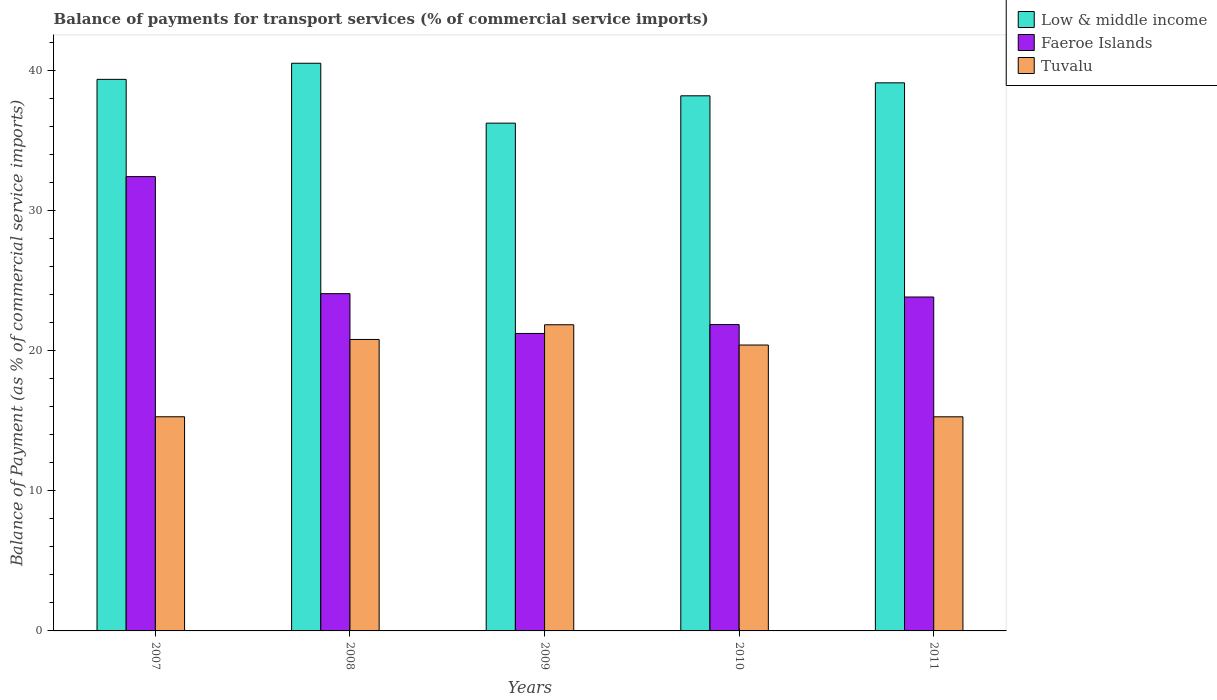Are the number of bars on each tick of the X-axis equal?
Provide a succinct answer. Yes. How many bars are there on the 5th tick from the left?
Your answer should be compact. 3. How many bars are there on the 5th tick from the right?
Make the answer very short. 3. What is the label of the 4th group of bars from the left?
Your response must be concise. 2010. What is the balance of payments for transport services in Faeroe Islands in 2010?
Your answer should be compact. 21.87. Across all years, what is the maximum balance of payments for transport services in Low & middle income?
Offer a terse response. 40.52. Across all years, what is the minimum balance of payments for transport services in Tuvalu?
Your answer should be compact. 15.28. In which year was the balance of payments for transport services in Low & middle income minimum?
Make the answer very short. 2009. What is the total balance of payments for transport services in Low & middle income in the graph?
Your response must be concise. 193.44. What is the difference between the balance of payments for transport services in Faeroe Islands in 2007 and that in 2011?
Give a very brief answer. 8.59. What is the difference between the balance of payments for transport services in Faeroe Islands in 2011 and the balance of payments for transport services in Tuvalu in 2008?
Offer a very short reply. 3.03. What is the average balance of payments for transport services in Low & middle income per year?
Your answer should be compact. 38.69. In the year 2008, what is the difference between the balance of payments for transport services in Tuvalu and balance of payments for transport services in Faeroe Islands?
Give a very brief answer. -3.27. In how many years, is the balance of payments for transport services in Low & middle income greater than 16 %?
Your response must be concise. 5. What is the ratio of the balance of payments for transport services in Low & middle income in 2008 to that in 2009?
Provide a succinct answer. 1.12. What is the difference between the highest and the second highest balance of payments for transport services in Low & middle income?
Offer a very short reply. 1.15. What is the difference between the highest and the lowest balance of payments for transport services in Faeroe Islands?
Offer a terse response. 11.19. In how many years, is the balance of payments for transport services in Low & middle income greater than the average balance of payments for transport services in Low & middle income taken over all years?
Provide a succinct answer. 3. Is the sum of the balance of payments for transport services in Faeroe Islands in 2007 and 2009 greater than the maximum balance of payments for transport services in Low & middle income across all years?
Keep it short and to the point. Yes. What does the 2nd bar from the left in 2008 represents?
Ensure brevity in your answer.  Faeroe Islands. What does the 3rd bar from the right in 2011 represents?
Give a very brief answer. Low & middle income. Is it the case that in every year, the sum of the balance of payments for transport services in Tuvalu and balance of payments for transport services in Low & middle income is greater than the balance of payments for transport services in Faeroe Islands?
Your answer should be very brief. Yes. How many years are there in the graph?
Provide a succinct answer. 5. What is the difference between two consecutive major ticks on the Y-axis?
Your answer should be compact. 10. Are the values on the major ticks of Y-axis written in scientific E-notation?
Offer a terse response. No. Does the graph contain grids?
Provide a short and direct response. No. Where does the legend appear in the graph?
Keep it short and to the point. Top right. How many legend labels are there?
Provide a short and direct response. 3. What is the title of the graph?
Offer a very short reply. Balance of payments for transport services (% of commercial service imports). Does "South Africa" appear as one of the legend labels in the graph?
Offer a very short reply. No. What is the label or title of the X-axis?
Offer a terse response. Years. What is the label or title of the Y-axis?
Provide a short and direct response. Balance of Payment (as % of commercial service imports). What is the Balance of Payment (as % of commercial service imports) in Low & middle income in 2007?
Your answer should be very brief. 39.37. What is the Balance of Payment (as % of commercial service imports) in Faeroe Islands in 2007?
Your answer should be compact. 32.43. What is the Balance of Payment (as % of commercial service imports) of Tuvalu in 2007?
Ensure brevity in your answer.  15.28. What is the Balance of Payment (as % of commercial service imports) of Low & middle income in 2008?
Provide a succinct answer. 40.52. What is the Balance of Payment (as % of commercial service imports) of Faeroe Islands in 2008?
Your response must be concise. 24.07. What is the Balance of Payment (as % of commercial service imports) in Tuvalu in 2008?
Provide a succinct answer. 20.8. What is the Balance of Payment (as % of commercial service imports) in Low & middle income in 2009?
Your answer should be compact. 36.24. What is the Balance of Payment (as % of commercial service imports) of Faeroe Islands in 2009?
Offer a very short reply. 21.23. What is the Balance of Payment (as % of commercial service imports) in Tuvalu in 2009?
Make the answer very short. 21.85. What is the Balance of Payment (as % of commercial service imports) of Low & middle income in 2010?
Offer a terse response. 38.19. What is the Balance of Payment (as % of commercial service imports) in Faeroe Islands in 2010?
Provide a short and direct response. 21.87. What is the Balance of Payment (as % of commercial service imports) in Tuvalu in 2010?
Offer a terse response. 20.41. What is the Balance of Payment (as % of commercial service imports) in Low & middle income in 2011?
Your response must be concise. 39.12. What is the Balance of Payment (as % of commercial service imports) of Faeroe Islands in 2011?
Ensure brevity in your answer.  23.83. What is the Balance of Payment (as % of commercial service imports) in Tuvalu in 2011?
Ensure brevity in your answer.  15.28. Across all years, what is the maximum Balance of Payment (as % of commercial service imports) in Low & middle income?
Keep it short and to the point. 40.52. Across all years, what is the maximum Balance of Payment (as % of commercial service imports) of Faeroe Islands?
Keep it short and to the point. 32.43. Across all years, what is the maximum Balance of Payment (as % of commercial service imports) of Tuvalu?
Offer a terse response. 21.85. Across all years, what is the minimum Balance of Payment (as % of commercial service imports) in Low & middle income?
Give a very brief answer. 36.24. Across all years, what is the minimum Balance of Payment (as % of commercial service imports) in Faeroe Islands?
Make the answer very short. 21.23. Across all years, what is the minimum Balance of Payment (as % of commercial service imports) of Tuvalu?
Offer a very short reply. 15.28. What is the total Balance of Payment (as % of commercial service imports) of Low & middle income in the graph?
Offer a terse response. 193.44. What is the total Balance of Payment (as % of commercial service imports) in Faeroe Islands in the graph?
Your answer should be compact. 123.43. What is the total Balance of Payment (as % of commercial service imports) of Tuvalu in the graph?
Keep it short and to the point. 93.63. What is the difference between the Balance of Payment (as % of commercial service imports) of Low & middle income in 2007 and that in 2008?
Offer a terse response. -1.15. What is the difference between the Balance of Payment (as % of commercial service imports) of Faeroe Islands in 2007 and that in 2008?
Provide a succinct answer. 8.35. What is the difference between the Balance of Payment (as % of commercial service imports) in Tuvalu in 2007 and that in 2008?
Provide a succinct answer. -5.52. What is the difference between the Balance of Payment (as % of commercial service imports) in Low & middle income in 2007 and that in 2009?
Your answer should be very brief. 3.13. What is the difference between the Balance of Payment (as % of commercial service imports) in Faeroe Islands in 2007 and that in 2009?
Your answer should be very brief. 11.19. What is the difference between the Balance of Payment (as % of commercial service imports) of Tuvalu in 2007 and that in 2009?
Offer a very short reply. -6.57. What is the difference between the Balance of Payment (as % of commercial service imports) of Low & middle income in 2007 and that in 2010?
Offer a very short reply. 1.17. What is the difference between the Balance of Payment (as % of commercial service imports) in Faeroe Islands in 2007 and that in 2010?
Make the answer very short. 10.56. What is the difference between the Balance of Payment (as % of commercial service imports) of Tuvalu in 2007 and that in 2010?
Provide a short and direct response. -5.12. What is the difference between the Balance of Payment (as % of commercial service imports) in Low & middle income in 2007 and that in 2011?
Keep it short and to the point. 0.25. What is the difference between the Balance of Payment (as % of commercial service imports) of Faeroe Islands in 2007 and that in 2011?
Keep it short and to the point. 8.59. What is the difference between the Balance of Payment (as % of commercial service imports) in Tuvalu in 2007 and that in 2011?
Offer a very short reply. 0. What is the difference between the Balance of Payment (as % of commercial service imports) in Low & middle income in 2008 and that in 2009?
Offer a very short reply. 4.27. What is the difference between the Balance of Payment (as % of commercial service imports) in Faeroe Islands in 2008 and that in 2009?
Offer a terse response. 2.84. What is the difference between the Balance of Payment (as % of commercial service imports) of Tuvalu in 2008 and that in 2009?
Your response must be concise. -1.05. What is the difference between the Balance of Payment (as % of commercial service imports) of Low & middle income in 2008 and that in 2010?
Your answer should be very brief. 2.32. What is the difference between the Balance of Payment (as % of commercial service imports) in Faeroe Islands in 2008 and that in 2010?
Ensure brevity in your answer.  2.21. What is the difference between the Balance of Payment (as % of commercial service imports) of Tuvalu in 2008 and that in 2010?
Ensure brevity in your answer.  0.4. What is the difference between the Balance of Payment (as % of commercial service imports) of Low & middle income in 2008 and that in 2011?
Your answer should be very brief. 1.4. What is the difference between the Balance of Payment (as % of commercial service imports) in Faeroe Islands in 2008 and that in 2011?
Your response must be concise. 0.24. What is the difference between the Balance of Payment (as % of commercial service imports) in Tuvalu in 2008 and that in 2011?
Your answer should be compact. 5.52. What is the difference between the Balance of Payment (as % of commercial service imports) of Low & middle income in 2009 and that in 2010?
Your answer should be very brief. -1.95. What is the difference between the Balance of Payment (as % of commercial service imports) in Faeroe Islands in 2009 and that in 2010?
Keep it short and to the point. -0.63. What is the difference between the Balance of Payment (as % of commercial service imports) in Tuvalu in 2009 and that in 2010?
Your answer should be very brief. 1.45. What is the difference between the Balance of Payment (as % of commercial service imports) of Low & middle income in 2009 and that in 2011?
Your answer should be very brief. -2.88. What is the difference between the Balance of Payment (as % of commercial service imports) of Faeroe Islands in 2009 and that in 2011?
Give a very brief answer. -2.6. What is the difference between the Balance of Payment (as % of commercial service imports) of Tuvalu in 2009 and that in 2011?
Provide a succinct answer. 6.57. What is the difference between the Balance of Payment (as % of commercial service imports) of Low & middle income in 2010 and that in 2011?
Give a very brief answer. -0.93. What is the difference between the Balance of Payment (as % of commercial service imports) of Faeroe Islands in 2010 and that in 2011?
Provide a succinct answer. -1.97. What is the difference between the Balance of Payment (as % of commercial service imports) in Tuvalu in 2010 and that in 2011?
Offer a very short reply. 5.12. What is the difference between the Balance of Payment (as % of commercial service imports) in Low & middle income in 2007 and the Balance of Payment (as % of commercial service imports) in Faeroe Islands in 2008?
Offer a very short reply. 15.3. What is the difference between the Balance of Payment (as % of commercial service imports) in Low & middle income in 2007 and the Balance of Payment (as % of commercial service imports) in Tuvalu in 2008?
Provide a short and direct response. 18.56. What is the difference between the Balance of Payment (as % of commercial service imports) in Faeroe Islands in 2007 and the Balance of Payment (as % of commercial service imports) in Tuvalu in 2008?
Your response must be concise. 11.62. What is the difference between the Balance of Payment (as % of commercial service imports) in Low & middle income in 2007 and the Balance of Payment (as % of commercial service imports) in Faeroe Islands in 2009?
Ensure brevity in your answer.  18.14. What is the difference between the Balance of Payment (as % of commercial service imports) in Low & middle income in 2007 and the Balance of Payment (as % of commercial service imports) in Tuvalu in 2009?
Make the answer very short. 17.52. What is the difference between the Balance of Payment (as % of commercial service imports) of Faeroe Islands in 2007 and the Balance of Payment (as % of commercial service imports) of Tuvalu in 2009?
Make the answer very short. 10.57. What is the difference between the Balance of Payment (as % of commercial service imports) of Low & middle income in 2007 and the Balance of Payment (as % of commercial service imports) of Faeroe Islands in 2010?
Offer a very short reply. 17.5. What is the difference between the Balance of Payment (as % of commercial service imports) of Low & middle income in 2007 and the Balance of Payment (as % of commercial service imports) of Tuvalu in 2010?
Offer a very short reply. 18.96. What is the difference between the Balance of Payment (as % of commercial service imports) in Faeroe Islands in 2007 and the Balance of Payment (as % of commercial service imports) in Tuvalu in 2010?
Your answer should be very brief. 12.02. What is the difference between the Balance of Payment (as % of commercial service imports) of Low & middle income in 2007 and the Balance of Payment (as % of commercial service imports) of Faeroe Islands in 2011?
Ensure brevity in your answer.  15.53. What is the difference between the Balance of Payment (as % of commercial service imports) of Low & middle income in 2007 and the Balance of Payment (as % of commercial service imports) of Tuvalu in 2011?
Provide a succinct answer. 24.09. What is the difference between the Balance of Payment (as % of commercial service imports) of Faeroe Islands in 2007 and the Balance of Payment (as % of commercial service imports) of Tuvalu in 2011?
Provide a succinct answer. 17.14. What is the difference between the Balance of Payment (as % of commercial service imports) in Low & middle income in 2008 and the Balance of Payment (as % of commercial service imports) in Faeroe Islands in 2009?
Your response must be concise. 19.29. What is the difference between the Balance of Payment (as % of commercial service imports) of Low & middle income in 2008 and the Balance of Payment (as % of commercial service imports) of Tuvalu in 2009?
Provide a short and direct response. 18.66. What is the difference between the Balance of Payment (as % of commercial service imports) in Faeroe Islands in 2008 and the Balance of Payment (as % of commercial service imports) in Tuvalu in 2009?
Provide a short and direct response. 2.22. What is the difference between the Balance of Payment (as % of commercial service imports) of Low & middle income in 2008 and the Balance of Payment (as % of commercial service imports) of Faeroe Islands in 2010?
Your response must be concise. 18.65. What is the difference between the Balance of Payment (as % of commercial service imports) in Low & middle income in 2008 and the Balance of Payment (as % of commercial service imports) in Tuvalu in 2010?
Your response must be concise. 20.11. What is the difference between the Balance of Payment (as % of commercial service imports) of Faeroe Islands in 2008 and the Balance of Payment (as % of commercial service imports) of Tuvalu in 2010?
Offer a terse response. 3.67. What is the difference between the Balance of Payment (as % of commercial service imports) of Low & middle income in 2008 and the Balance of Payment (as % of commercial service imports) of Faeroe Islands in 2011?
Your response must be concise. 16.68. What is the difference between the Balance of Payment (as % of commercial service imports) of Low & middle income in 2008 and the Balance of Payment (as % of commercial service imports) of Tuvalu in 2011?
Keep it short and to the point. 25.23. What is the difference between the Balance of Payment (as % of commercial service imports) of Faeroe Islands in 2008 and the Balance of Payment (as % of commercial service imports) of Tuvalu in 2011?
Offer a very short reply. 8.79. What is the difference between the Balance of Payment (as % of commercial service imports) in Low & middle income in 2009 and the Balance of Payment (as % of commercial service imports) in Faeroe Islands in 2010?
Your answer should be very brief. 14.38. What is the difference between the Balance of Payment (as % of commercial service imports) of Low & middle income in 2009 and the Balance of Payment (as % of commercial service imports) of Tuvalu in 2010?
Provide a succinct answer. 15.84. What is the difference between the Balance of Payment (as % of commercial service imports) of Faeroe Islands in 2009 and the Balance of Payment (as % of commercial service imports) of Tuvalu in 2010?
Your answer should be compact. 0.83. What is the difference between the Balance of Payment (as % of commercial service imports) in Low & middle income in 2009 and the Balance of Payment (as % of commercial service imports) in Faeroe Islands in 2011?
Make the answer very short. 12.41. What is the difference between the Balance of Payment (as % of commercial service imports) in Low & middle income in 2009 and the Balance of Payment (as % of commercial service imports) in Tuvalu in 2011?
Offer a very short reply. 20.96. What is the difference between the Balance of Payment (as % of commercial service imports) of Faeroe Islands in 2009 and the Balance of Payment (as % of commercial service imports) of Tuvalu in 2011?
Make the answer very short. 5.95. What is the difference between the Balance of Payment (as % of commercial service imports) in Low & middle income in 2010 and the Balance of Payment (as % of commercial service imports) in Faeroe Islands in 2011?
Your answer should be very brief. 14.36. What is the difference between the Balance of Payment (as % of commercial service imports) of Low & middle income in 2010 and the Balance of Payment (as % of commercial service imports) of Tuvalu in 2011?
Ensure brevity in your answer.  22.91. What is the difference between the Balance of Payment (as % of commercial service imports) of Faeroe Islands in 2010 and the Balance of Payment (as % of commercial service imports) of Tuvalu in 2011?
Offer a terse response. 6.58. What is the average Balance of Payment (as % of commercial service imports) in Low & middle income per year?
Offer a very short reply. 38.69. What is the average Balance of Payment (as % of commercial service imports) in Faeroe Islands per year?
Make the answer very short. 24.69. What is the average Balance of Payment (as % of commercial service imports) in Tuvalu per year?
Offer a terse response. 18.73. In the year 2007, what is the difference between the Balance of Payment (as % of commercial service imports) of Low & middle income and Balance of Payment (as % of commercial service imports) of Faeroe Islands?
Your answer should be compact. 6.94. In the year 2007, what is the difference between the Balance of Payment (as % of commercial service imports) of Low & middle income and Balance of Payment (as % of commercial service imports) of Tuvalu?
Your answer should be compact. 24.08. In the year 2007, what is the difference between the Balance of Payment (as % of commercial service imports) in Faeroe Islands and Balance of Payment (as % of commercial service imports) in Tuvalu?
Provide a succinct answer. 17.14. In the year 2008, what is the difference between the Balance of Payment (as % of commercial service imports) of Low & middle income and Balance of Payment (as % of commercial service imports) of Faeroe Islands?
Make the answer very short. 16.45. In the year 2008, what is the difference between the Balance of Payment (as % of commercial service imports) of Low & middle income and Balance of Payment (as % of commercial service imports) of Tuvalu?
Your response must be concise. 19.71. In the year 2008, what is the difference between the Balance of Payment (as % of commercial service imports) in Faeroe Islands and Balance of Payment (as % of commercial service imports) in Tuvalu?
Provide a short and direct response. 3.27. In the year 2009, what is the difference between the Balance of Payment (as % of commercial service imports) of Low & middle income and Balance of Payment (as % of commercial service imports) of Faeroe Islands?
Offer a terse response. 15.01. In the year 2009, what is the difference between the Balance of Payment (as % of commercial service imports) in Low & middle income and Balance of Payment (as % of commercial service imports) in Tuvalu?
Keep it short and to the point. 14.39. In the year 2009, what is the difference between the Balance of Payment (as % of commercial service imports) of Faeroe Islands and Balance of Payment (as % of commercial service imports) of Tuvalu?
Provide a short and direct response. -0.62. In the year 2010, what is the difference between the Balance of Payment (as % of commercial service imports) in Low & middle income and Balance of Payment (as % of commercial service imports) in Faeroe Islands?
Keep it short and to the point. 16.33. In the year 2010, what is the difference between the Balance of Payment (as % of commercial service imports) in Low & middle income and Balance of Payment (as % of commercial service imports) in Tuvalu?
Your answer should be very brief. 17.79. In the year 2010, what is the difference between the Balance of Payment (as % of commercial service imports) of Faeroe Islands and Balance of Payment (as % of commercial service imports) of Tuvalu?
Offer a terse response. 1.46. In the year 2011, what is the difference between the Balance of Payment (as % of commercial service imports) of Low & middle income and Balance of Payment (as % of commercial service imports) of Faeroe Islands?
Your response must be concise. 15.29. In the year 2011, what is the difference between the Balance of Payment (as % of commercial service imports) of Low & middle income and Balance of Payment (as % of commercial service imports) of Tuvalu?
Your answer should be very brief. 23.84. In the year 2011, what is the difference between the Balance of Payment (as % of commercial service imports) of Faeroe Islands and Balance of Payment (as % of commercial service imports) of Tuvalu?
Your answer should be very brief. 8.55. What is the ratio of the Balance of Payment (as % of commercial service imports) in Low & middle income in 2007 to that in 2008?
Make the answer very short. 0.97. What is the ratio of the Balance of Payment (as % of commercial service imports) in Faeroe Islands in 2007 to that in 2008?
Your answer should be very brief. 1.35. What is the ratio of the Balance of Payment (as % of commercial service imports) of Tuvalu in 2007 to that in 2008?
Ensure brevity in your answer.  0.73. What is the ratio of the Balance of Payment (as % of commercial service imports) in Low & middle income in 2007 to that in 2009?
Keep it short and to the point. 1.09. What is the ratio of the Balance of Payment (as % of commercial service imports) of Faeroe Islands in 2007 to that in 2009?
Make the answer very short. 1.53. What is the ratio of the Balance of Payment (as % of commercial service imports) of Tuvalu in 2007 to that in 2009?
Make the answer very short. 0.7. What is the ratio of the Balance of Payment (as % of commercial service imports) of Low & middle income in 2007 to that in 2010?
Offer a terse response. 1.03. What is the ratio of the Balance of Payment (as % of commercial service imports) in Faeroe Islands in 2007 to that in 2010?
Your response must be concise. 1.48. What is the ratio of the Balance of Payment (as % of commercial service imports) of Tuvalu in 2007 to that in 2010?
Give a very brief answer. 0.75. What is the ratio of the Balance of Payment (as % of commercial service imports) in Faeroe Islands in 2007 to that in 2011?
Your response must be concise. 1.36. What is the ratio of the Balance of Payment (as % of commercial service imports) of Low & middle income in 2008 to that in 2009?
Provide a succinct answer. 1.12. What is the ratio of the Balance of Payment (as % of commercial service imports) in Faeroe Islands in 2008 to that in 2009?
Offer a very short reply. 1.13. What is the ratio of the Balance of Payment (as % of commercial service imports) in Low & middle income in 2008 to that in 2010?
Your response must be concise. 1.06. What is the ratio of the Balance of Payment (as % of commercial service imports) of Faeroe Islands in 2008 to that in 2010?
Offer a very short reply. 1.1. What is the ratio of the Balance of Payment (as % of commercial service imports) in Tuvalu in 2008 to that in 2010?
Your response must be concise. 1.02. What is the ratio of the Balance of Payment (as % of commercial service imports) of Low & middle income in 2008 to that in 2011?
Your answer should be very brief. 1.04. What is the ratio of the Balance of Payment (as % of commercial service imports) of Faeroe Islands in 2008 to that in 2011?
Ensure brevity in your answer.  1.01. What is the ratio of the Balance of Payment (as % of commercial service imports) in Tuvalu in 2008 to that in 2011?
Offer a terse response. 1.36. What is the ratio of the Balance of Payment (as % of commercial service imports) of Low & middle income in 2009 to that in 2010?
Offer a very short reply. 0.95. What is the ratio of the Balance of Payment (as % of commercial service imports) of Tuvalu in 2009 to that in 2010?
Your response must be concise. 1.07. What is the ratio of the Balance of Payment (as % of commercial service imports) in Low & middle income in 2009 to that in 2011?
Provide a succinct answer. 0.93. What is the ratio of the Balance of Payment (as % of commercial service imports) of Faeroe Islands in 2009 to that in 2011?
Offer a very short reply. 0.89. What is the ratio of the Balance of Payment (as % of commercial service imports) in Tuvalu in 2009 to that in 2011?
Offer a terse response. 1.43. What is the ratio of the Balance of Payment (as % of commercial service imports) in Low & middle income in 2010 to that in 2011?
Offer a very short reply. 0.98. What is the ratio of the Balance of Payment (as % of commercial service imports) in Faeroe Islands in 2010 to that in 2011?
Your response must be concise. 0.92. What is the ratio of the Balance of Payment (as % of commercial service imports) in Tuvalu in 2010 to that in 2011?
Keep it short and to the point. 1.34. What is the difference between the highest and the second highest Balance of Payment (as % of commercial service imports) of Low & middle income?
Make the answer very short. 1.15. What is the difference between the highest and the second highest Balance of Payment (as % of commercial service imports) of Faeroe Islands?
Offer a very short reply. 8.35. What is the difference between the highest and the second highest Balance of Payment (as % of commercial service imports) in Tuvalu?
Make the answer very short. 1.05. What is the difference between the highest and the lowest Balance of Payment (as % of commercial service imports) in Low & middle income?
Provide a short and direct response. 4.27. What is the difference between the highest and the lowest Balance of Payment (as % of commercial service imports) in Faeroe Islands?
Provide a succinct answer. 11.19. What is the difference between the highest and the lowest Balance of Payment (as % of commercial service imports) in Tuvalu?
Your answer should be very brief. 6.57. 